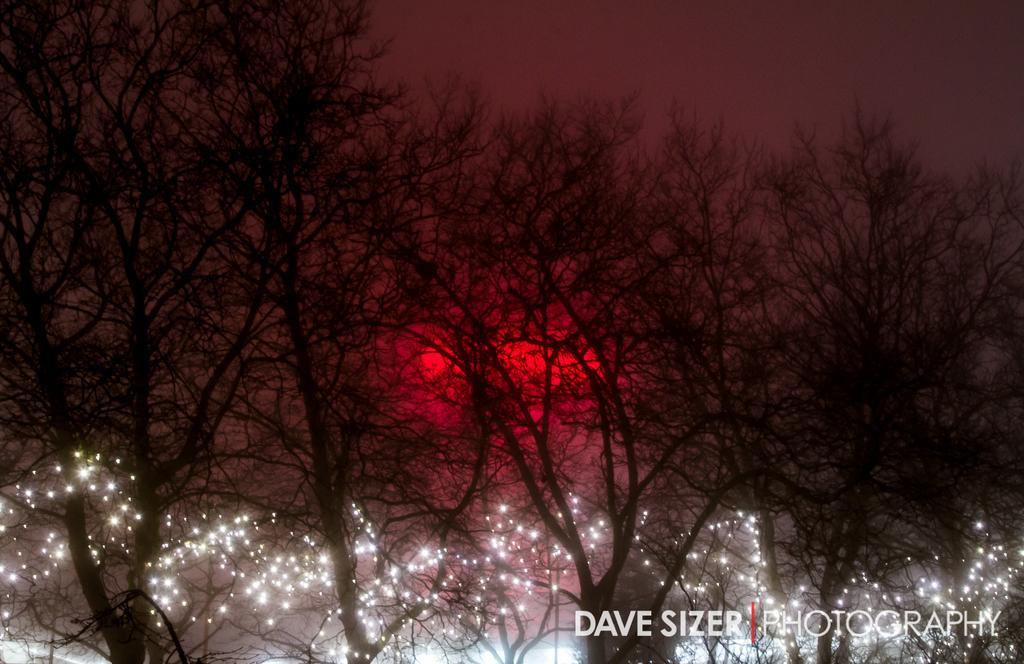Please provide a concise description of this image. In this image I can see few dry trees, lights and the background is in red, black and grey color. 